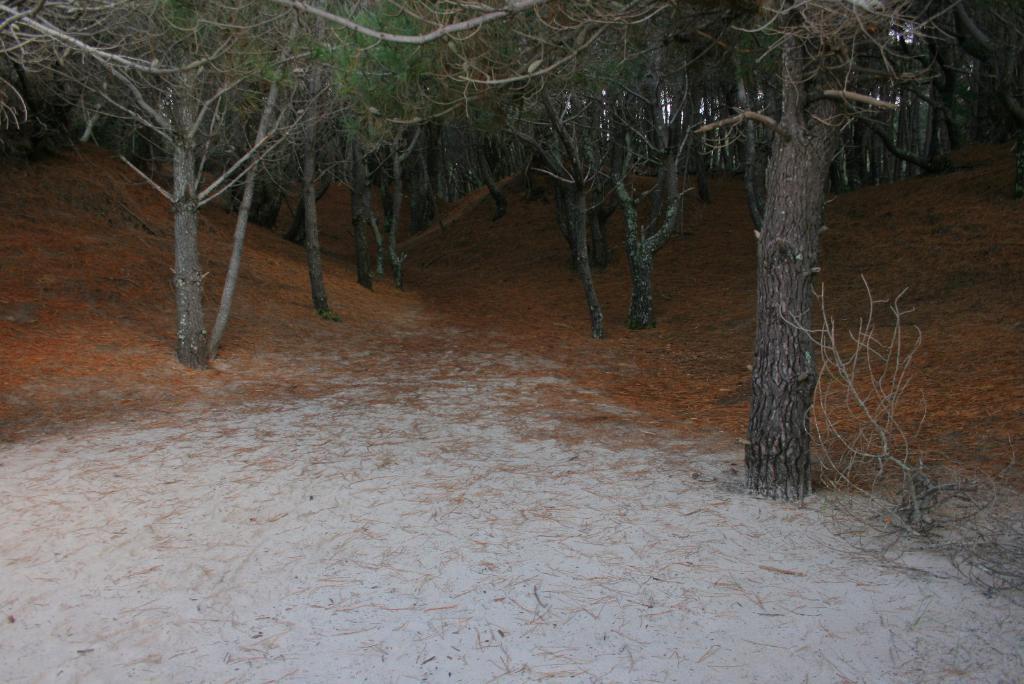Please provide a concise description of this image. In this image there are few trees, plants and dried leaves are on the land. 